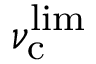Convert formula to latex. <formula><loc_0><loc_0><loc_500><loc_500>\nu _ { c } ^ { l i m }</formula> 